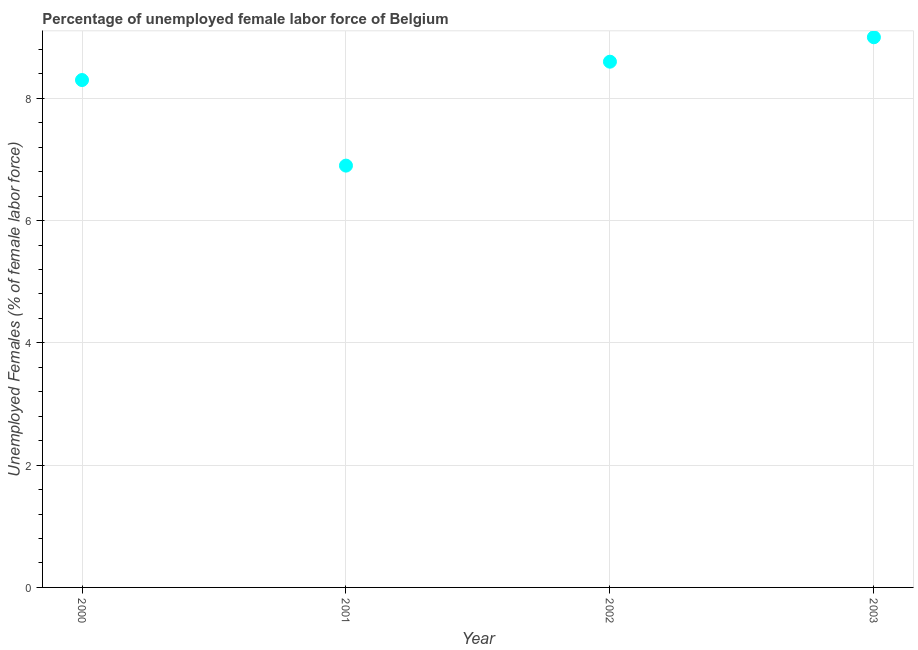What is the total unemployed female labour force in 2000?
Provide a succinct answer. 8.3. Across all years, what is the minimum total unemployed female labour force?
Give a very brief answer. 6.9. In which year was the total unemployed female labour force maximum?
Your answer should be very brief. 2003. What is the sum of the total unemployed female labour force?
Offer a very short reply. 32.8. What is the difference between the total unemployed female labour force in 2000 and 2002?
Your answer should be compact. -0.3. What is the average total unemployed female labour force per year?
Ensure brevity in your answer.  8.2. What is the median total unemployed female labour force?
Keep it short and to the point. 8.45. In how many years, is the total unemployed female labour force greater than 3.6 %?
Provide a short and direct response. 4. What is the ratio of the total unemployed female labour force in 2000 to that in 2002?
Make the answer very short. 0.97. What is the difference between the highest and the second highest total unemployed female labour force?
Your answer should be very brief. 0.4. What is the difference between the highest and the lowest total unemployed female labour force?
Your answer should be compact. 2.1. In how many years, is the total unemployed female labour force greater than the average total unemployed female labour force taken over all years?
Your answer should be compact. 3. Does the total unemployed female labour force monotonically increase over the years?
Provide a succinct answer. No. How many dotlines are there?
Your answer should be very brief. 1. What is the difference between two consecutive major ticks on the Y-axis?
Your response must be concise. 2. Does the graph contain any zero values?
Offer a very short reply. No. What is the title of the graph?
Make the answer very short. Percentage of unemployed female labor force of Belgium. What is the label or title of the X-axis?
Your response must be concise. Year. What is the label or title of the Y-axis?
Give a very brief answer. Unemployed Females (% of female labor force). What is the Unemployed Females (% of female labor force) in 2000?
Provide a short and direct response. 8.3. What is the Unemployed Females (% of female labor force) in 2001?
Your answer should be compact. 6.9. What is the Unemployed Females (% of female labor force) in 2002?
Your response must be concise. 8.6. What is the difference between the Unemployed Females (% of female labor force) in 2000 and 2002?
Offer a terse response. -0.3. What is the difference between the Unemployed Females (% of female labor force) in 2001 and 2003?
Ensure brevity in your answer.  -2.1. What is the ratio of the Unemployed Females (% of female labor force) in 2000 to that in 2001?
Provide a succinct answer. 1.2. What is the ratio of the Unemployed Females (% of female labor force) in 2000 to that in 2002?
Make the answer very short. 0.96. What is the ratio of the Unemployed Females (% of female labor force) in 2000 to that in 2003?
Provide a short and direct response. 0.92. What is the ratio of the Unemployed Females (% of female labor force) in 2001 to that in 2002?
Your answer should be very brief. 0.8. What is the ratio of the Unemployed Females (% of female labor force) in 2001 to that in 2003?
Keep it short and to the point. 0.77. What is the ratio of the Unemployed Females (% of female labor force) in 2002 to that in 2003?
Make the answer very short. 0.96. 